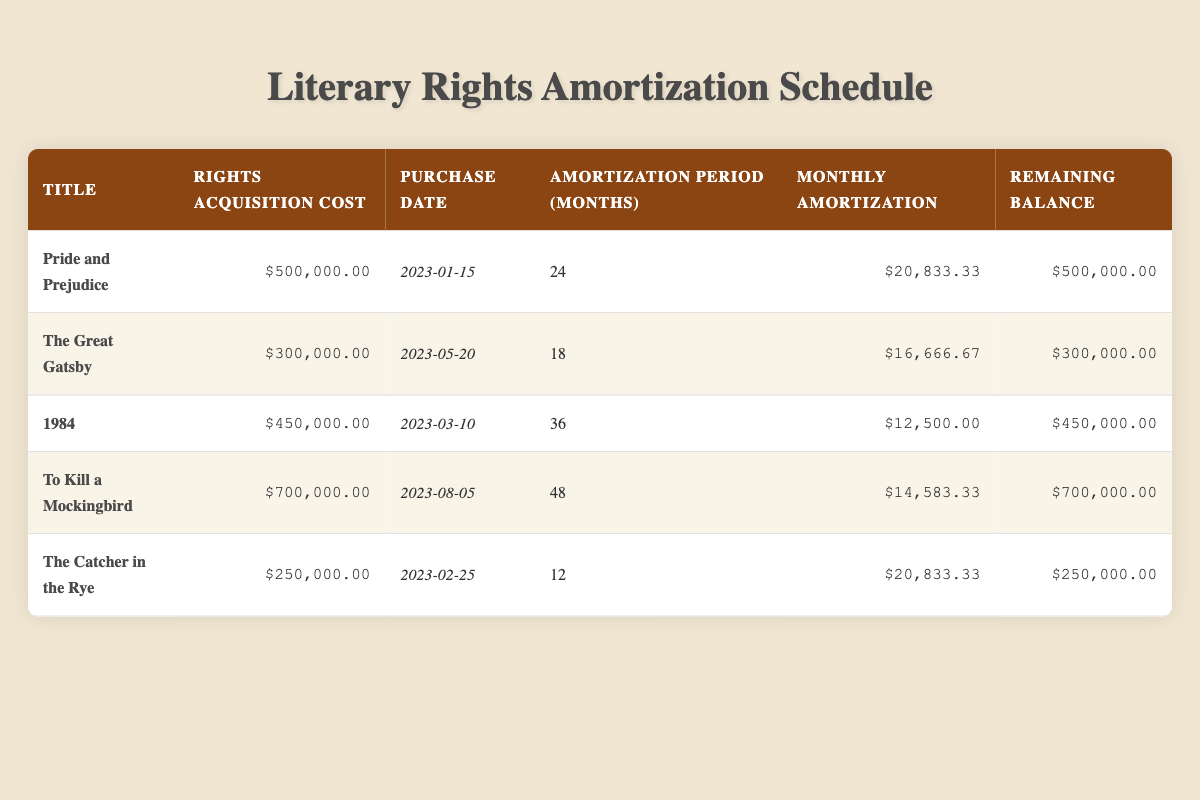What is the rights acquisition cost for "1984"? The table shows the rights acquisition cost for "1984" listed in the respective column, which is $450,000.00.
Answer: $450,000.00 How long is the amortization period for "The Great Gatsby"? The amortization period for "The Great Gatsby" is specified in the table under "Amortization Period (Months)", which indicates it is 18 months.
Answer: 18 months Which title has the highest remaining balance? By examining the "Remaining Balance" column for all titles, "To Kill a Mockingbird" has the highest remaining balance of $700,000.00.
Answer: To Kill a Mockingbird What is the total rights acquisition cost of all the titles listed? To get the total rights acquisition cost, we need to sum the costs of each title: 500000 + 300000 + 450000 + 700000 + 250000 = 2200000.
Answer: $2,200,000.00 Is the monthly amortization of "Pride and Prejudice" greater than that of "The Catcher in the Rye"? Comparing the monthly amortization figures, "Pride and Prejudice" has a monthly amortization of $20,833.33, while "The Catcher in the Rye" has $20,833.33. Since they are equal, the answer is false.
Answer: No How much more does "To Kill a Mockingbird" cost compared to "The Great Gatsby"? We need to subtract the rights acquisition cost of "The Great Gatsby" from that of "To Kill a Mockingbird": 700000 - 300000 = 400000.
Answer: $400,000.00 Which title has the earliest purchase date, and how many months does it have until the end of its amortization period? "Pride and Prejudice" has the earliest purchase date of 2023-01-15. Its amortization period is 24 months, thus ending on 2025-01-15, which gives it 24 months until completion.
Answer: Pride and Prejudice, 24 months If one were to pay all remaining balances at once, what would that total be? We total the remaining balances from the table: 500000 + 300000 + 450000 + 700000 + 250000 = 2200000.
Answer: $2,200,000.00 How many titles have a monthly amortization of less than $15,000? We check the "Monthly Amortization" column. Only "1984" ($12,500.00) fits this criterion, so there is 1 title.
Answer: 1 